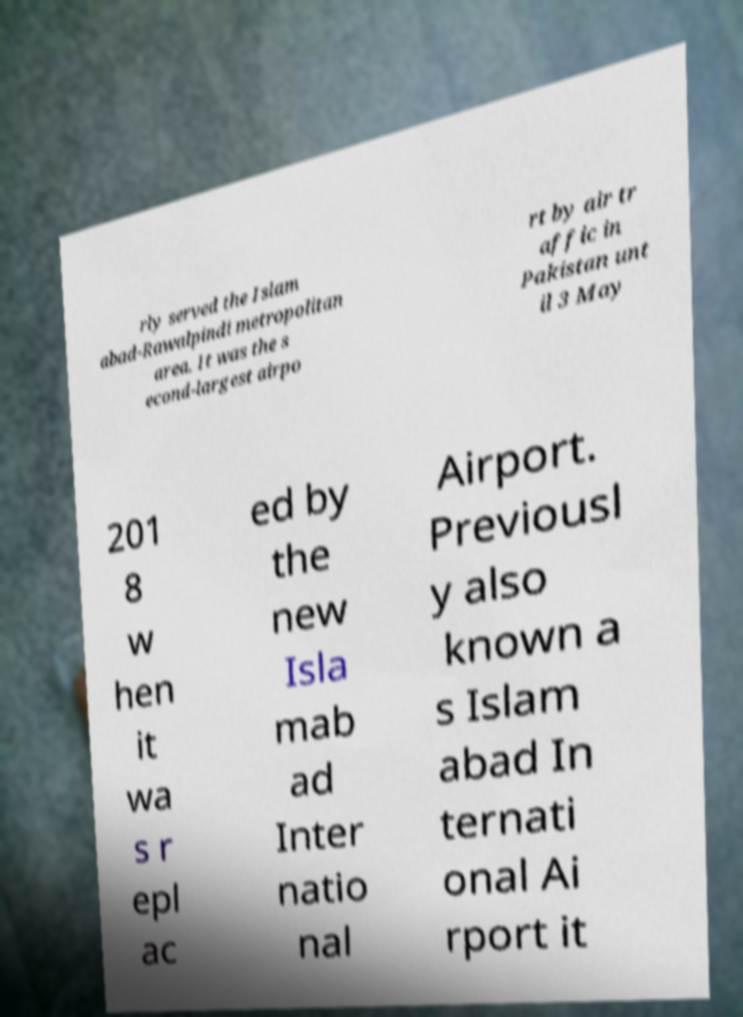What messages or text are displayed in this image? I need them in a readable, typed format. rly served the Islam abad-Rawalpindi metropolitan area. It was the s econd-largest airpo rt by air tr affic in Pakistan unt il 3 May 201 8 w hen it wa s r epl ac ed by the new Isla mab ad Inter natio nal Airport. Previousl y also known a s Islam abad In ternati onal Ai rport it 